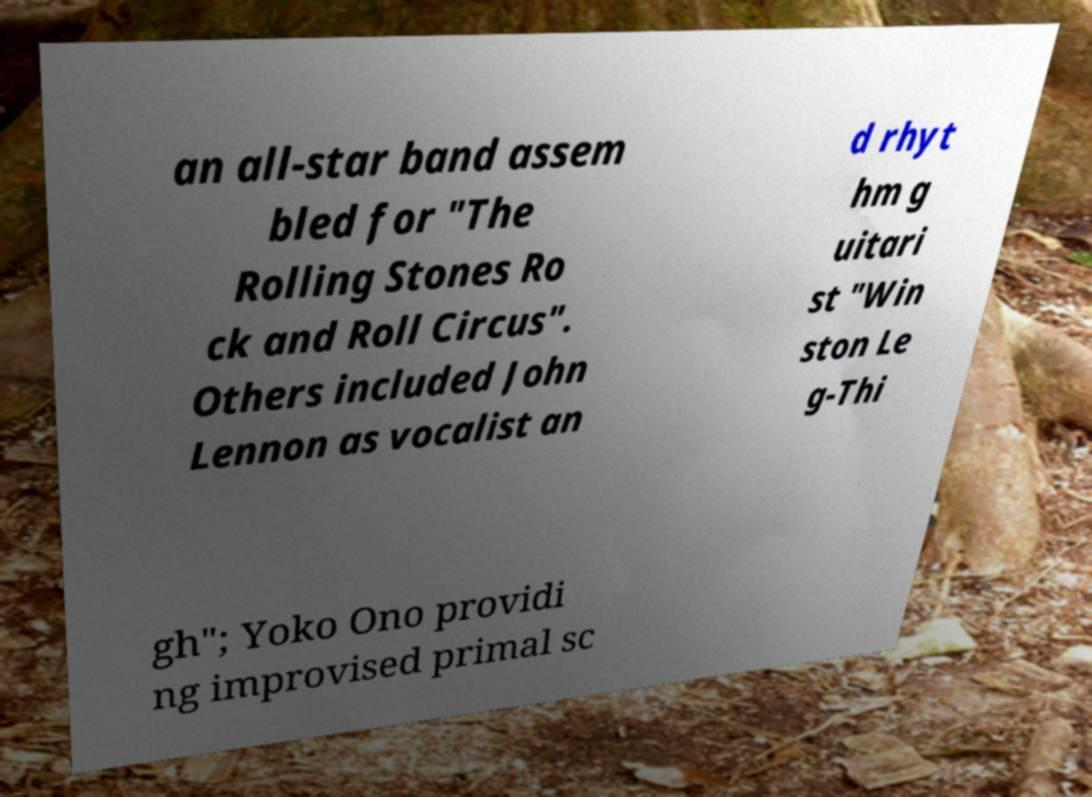I need the written content from this picture converted into text. Can you do that? an all-star band assem bled for "The Rolling Stones Ro ck and Roll Circus". Others included John Lennon as vocalist an d rhyt hm g uitari st "Win ston Le g-Thi gh"; Yoko Ono providi ng improvised primal sc 